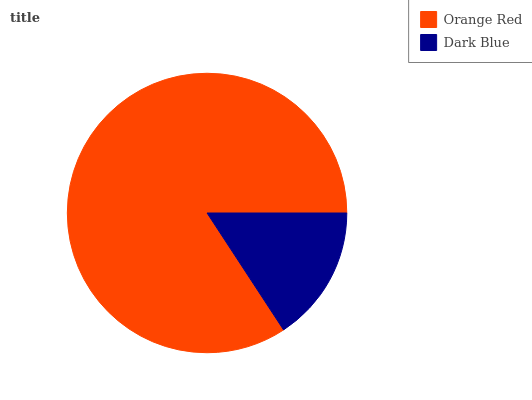Is Dark Blue the minimum?
Answer yes or no. Yes. Is Orange Red the maximum?
Answer yes or no. Yes. Is Dark Blue the maximum?
Answer yes or no. No. Is Orange Red greater than Dark Blue?
Answer yes or no. Yes. Is Dark Blue less than Orange Red?
Answer yes or no. Yes. Is Dark Blue greater than Orange Red?
Answer yes or no. No. Is Orange Red less than Dark Blue?
Answer yes or no. No. Is Orange Red the high median?
Answer yes or no. Yes. Is Dark Blue the low median?
Answer yes or no. Yes. Is Dark Blue the high median?
Answer yes or no. No. Is Orange Red the low median?
Answer yes or no. No. 